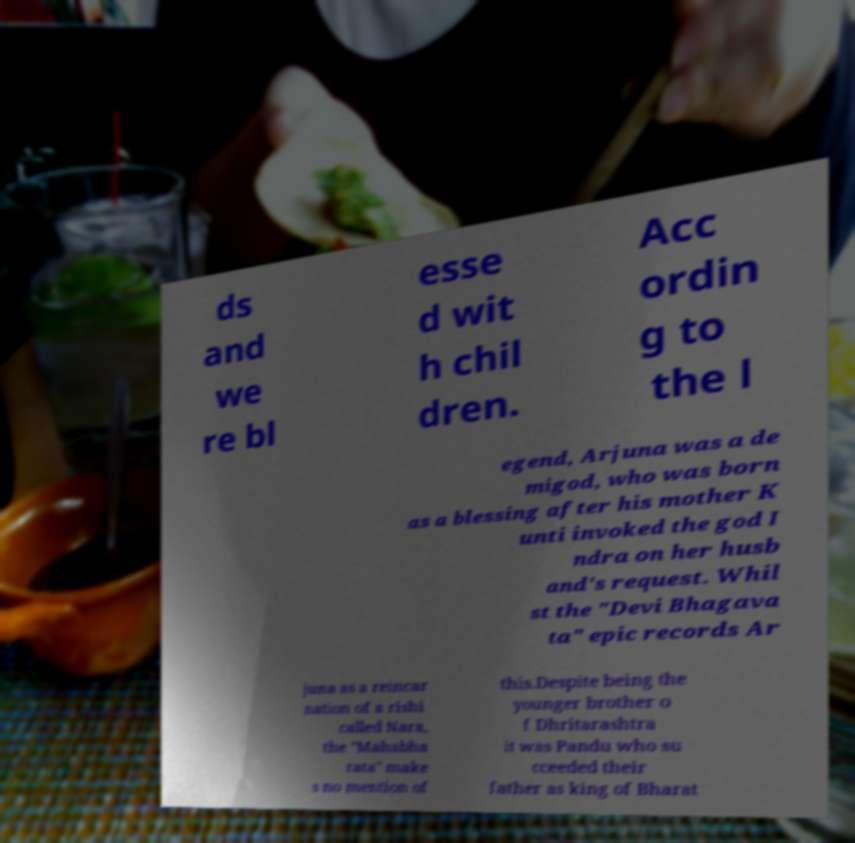There's text embedded in this image that I need extracted. Can you transcribe it verbatim? ds and we re bl esse d wit h chil dren. Acc ordin g to the l egend, Arjuna was a de migod, who was born as a blessing after his mother K unti invoked the god I ndra on her husb and's request. Whil st the "Devi Bhagava ta" epic records Ar juna as a reincar nation of a rishi called Nara, the "Mahabha rata" make s no mention of this.Despite being the younger brother o f Dhritarashtra it was Pandu who su cceeded their father as king of Bharat 